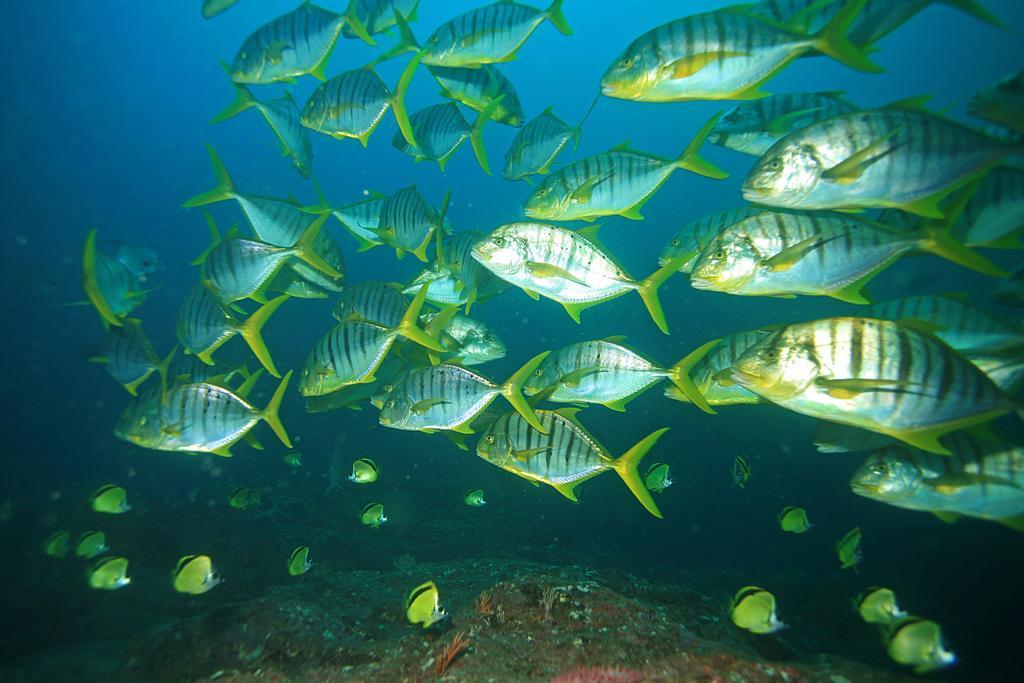Can you describe this image briefly? In this image there are fishes and reefs in water. 